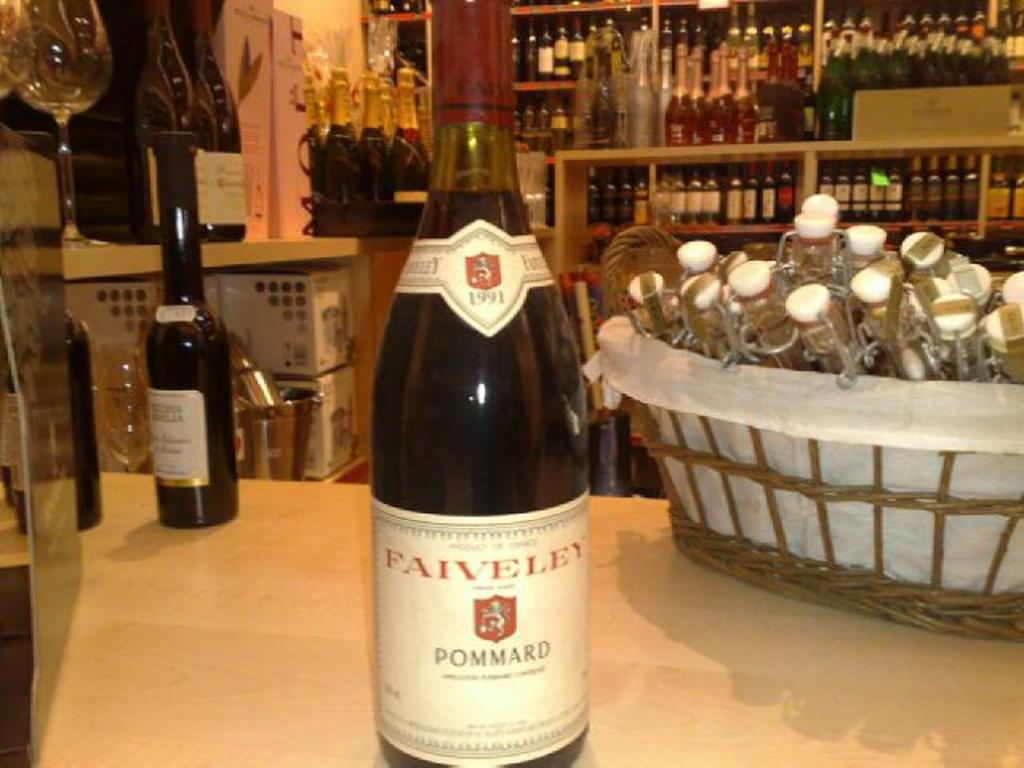How many bottles are visible in the image? There are two bottles and a basket full of bottles in the image. Where are the bottles located in the image? The bottles are on a table in the image. What can be seen in the background of the image? There is a wine rack in the background of the image. How much glue is needed to fix the broken bottle in the image? There is no broken bottle in the image, so the amount of glue needed cannot be determined. 